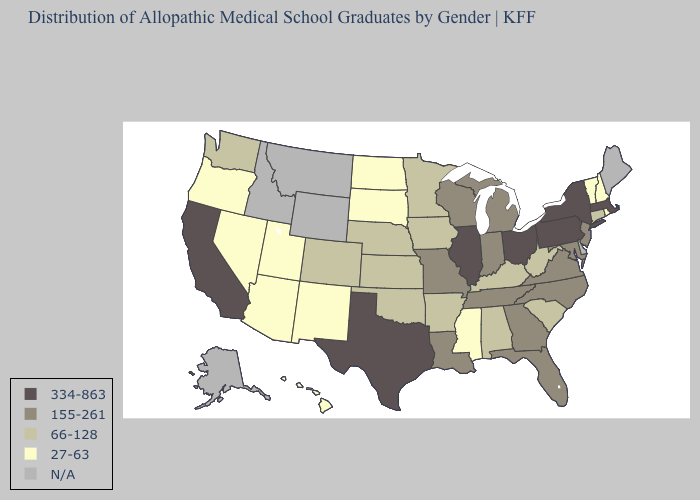What is the highest value in the Northeast ?
Short answer required. 334-863. What is the highest value in states that border Maine?
Short answer required. 27-63. What is the value of Kansas?
Write a very short answer. 66-128. Name the states that have a value in the range 334-863?
Give a very brief answer. California, Illinois, Massachusetts, New York, Ohio, Pennsylvania, Texas. What is the value of Massachusetts?
Keep it brief. 334-863. What is the value of Texas?
Keep it brief. 334-863. What is the value of West Virginia?
Give a very brief answer. 66-128. Which states have the highest value in the USA?
Write a very short answer. California, Illinois, Massachusetts, New York, Ohio, Pennsylvania, Texas. Does the map have missing data?
Short answer required. Yes. Name the states that have a value in the range N/A?
Short answer required. Alaska, Delaware, Idaho, Maine, Montana, Wyoming. What is the value of South Carolina?
Quick response, please. 66-128. Among the states that border Wisconsin , which have the highest value?
Answer briefly. Illinois. What is the highest value in the West ?
Keep it brief. 334-863. Which states have the lowest value in the West?
Give a very brief answer. Arizona, Hawaii, Nevada, New Mexico, Oregon, Utah. Among the states that border Wyoming , which have the highest value?
Keep it brief. Colorado, Nebraska. 